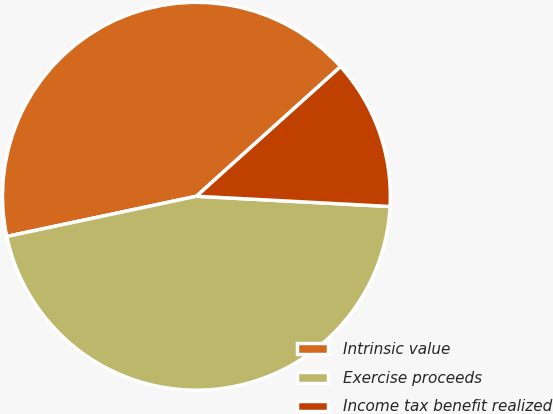Convert chart. <chart><loc_0><loc_0><loc_500><loc_500><pie_chart><fcel>Intrinsic value<fcel>Exercise proceeds<fcel>Income tax benefit realized<nl><fcel>41.67%<fcel>45.83%<fcel>12.5%<nl></chart> 